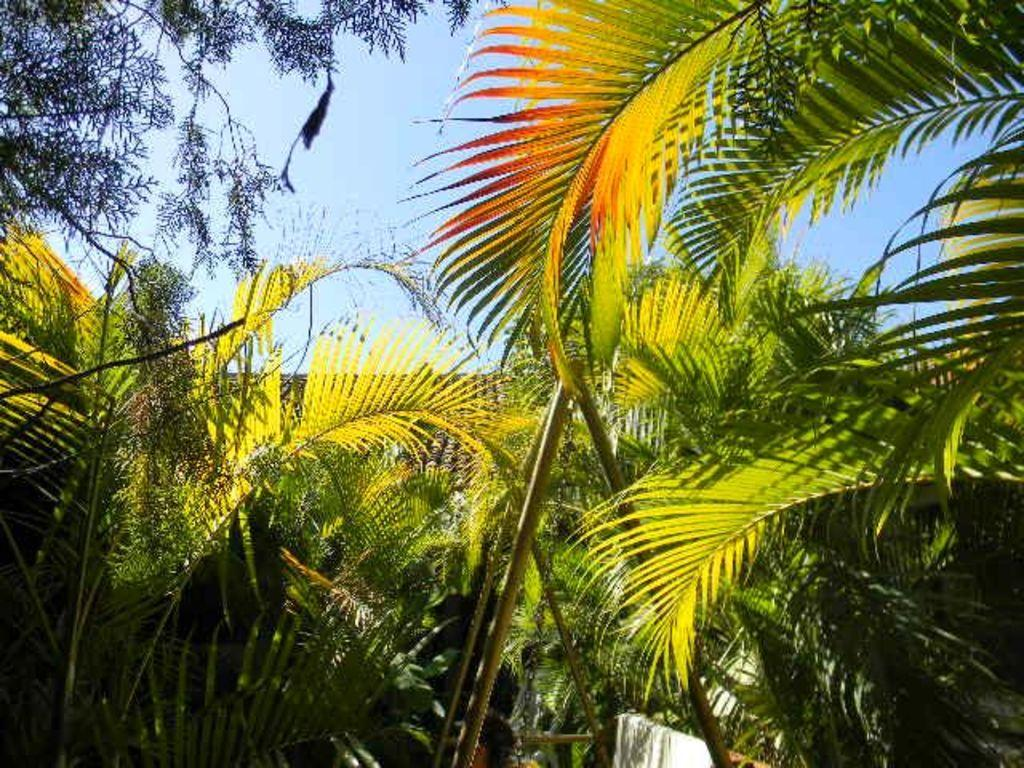What type of vegetation can be seen in the image? There are trees in the image. What object is present for recreational purposes? There is a swing in the image. What can be seen in the background of the image? The sky is visible in the background of the image. What type of paste is being used by the mice in the image? There are no mice present in the image, so there is no paste being used. 